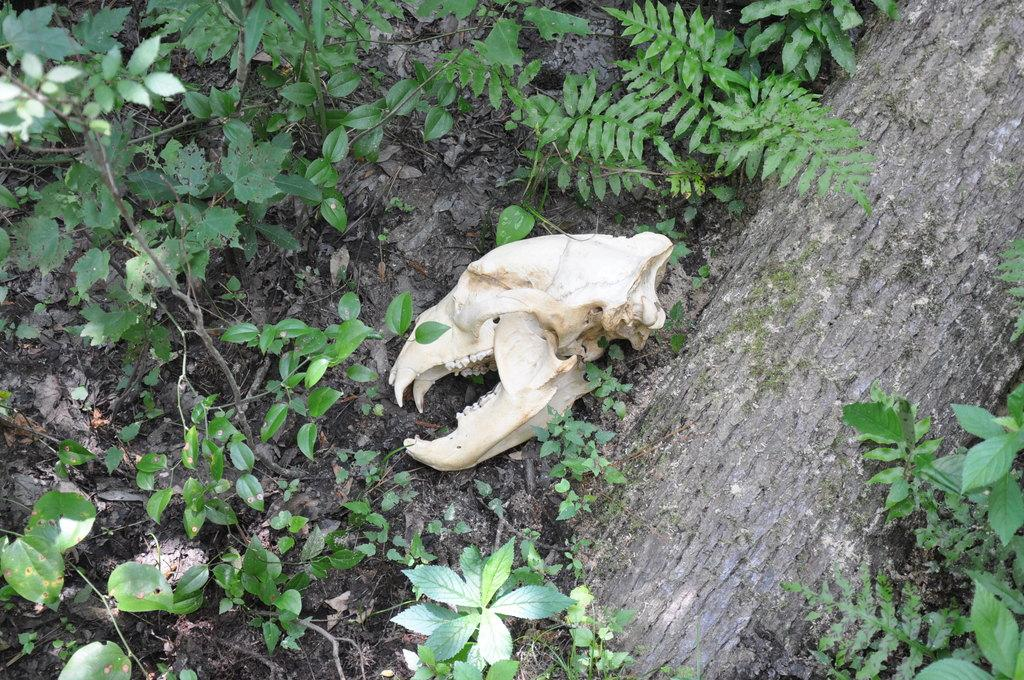What is the main subject of the image? There is a skull of an animal in the image. What can be seen in the background of the image? There are plants in the background of the image. What is the color of the plants in the image? The plants are green in color. How many nuts are visible in the image? There are no nuts present in the image. What type of planes can be seen flying in the background of the image? There are no planes visible in the image; it only features a skull and plants. 